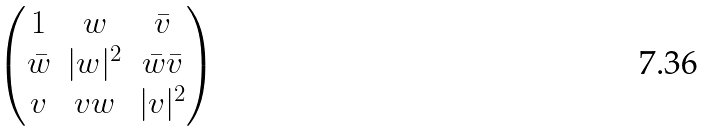<formula> <loc_0><loc_0><loc_500><loc_500>\begin{pmatrix} 1 & w & \bar { v } \\ \bar { w } & | w | ^ { 2 } & \bar { w } \bar { v } \\ v & v w & | v | ^ { 2 } \\ \end{pmatrix}</formula> 